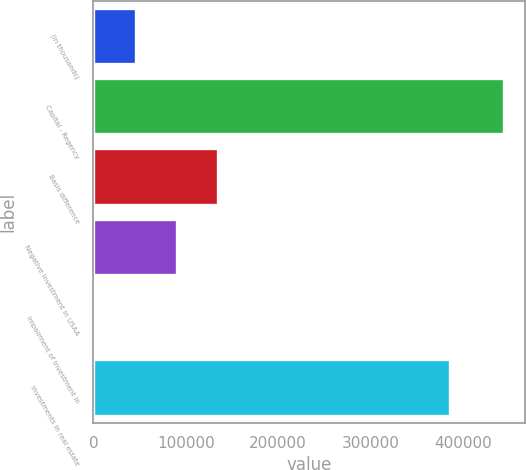Convert chart to OTSL. <chart><loc_0><loc_0><loc_500><loc_500><bar_chart><fcel>(in thousands)<fcel>Capital - Regency<fcel>Basis difference<fcel>Negative investment in USAA<fcel>Impairment of investment in<fcel>Investments in real estate<nl><fcel>45676.8<fcel>445068<fcel>134430<fcel>90053.6<fcel>1300<fcel>386304<nl></chart> 